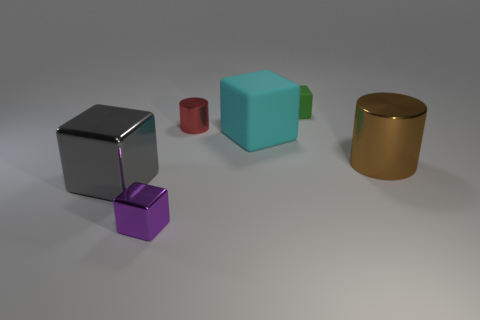Subtract all yellow cylinders. Subtract all green cubes. How many cylinders are left? 2 Add 3 brown metallic cylinders. How many objects exist? 9 Subtract all cylinders. How many objects are left? 4 Subtract all big metallic cylinders. Subtract all small green things. How many objects are left? 4 Add 1 brown metal cylinders. How many brown metal cylinders are left? 2 Add 3 tiny purple objects. How many tiny purple objects exist? 4 Subtract 0 blue cylinders. How many objects are left? 6 